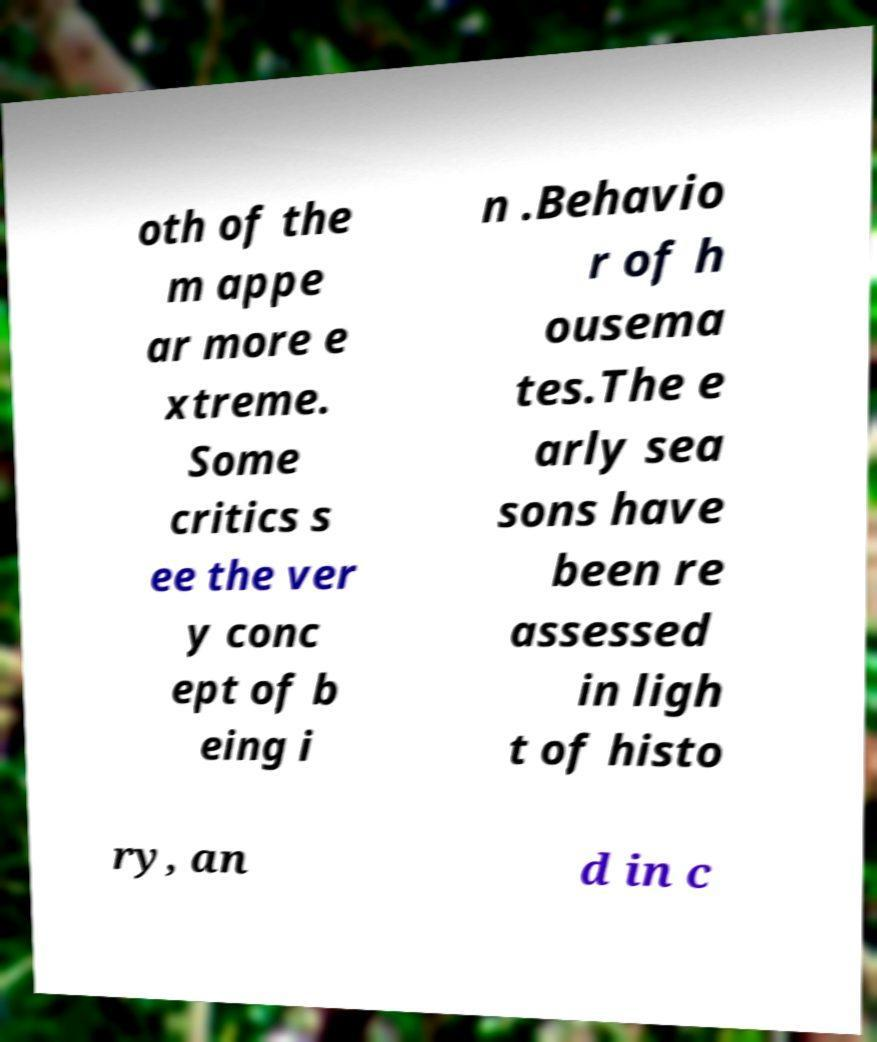What messages or text are displayed in this image? I need them in a readable, typed format. oth of the m appe ar more e xtreme. Some critics s ee the ver y conc ept of b eing i n .Behavio r of h ousema tes.The e arly sea sons have been re assessed in ligh t of histo ry, an d in c 